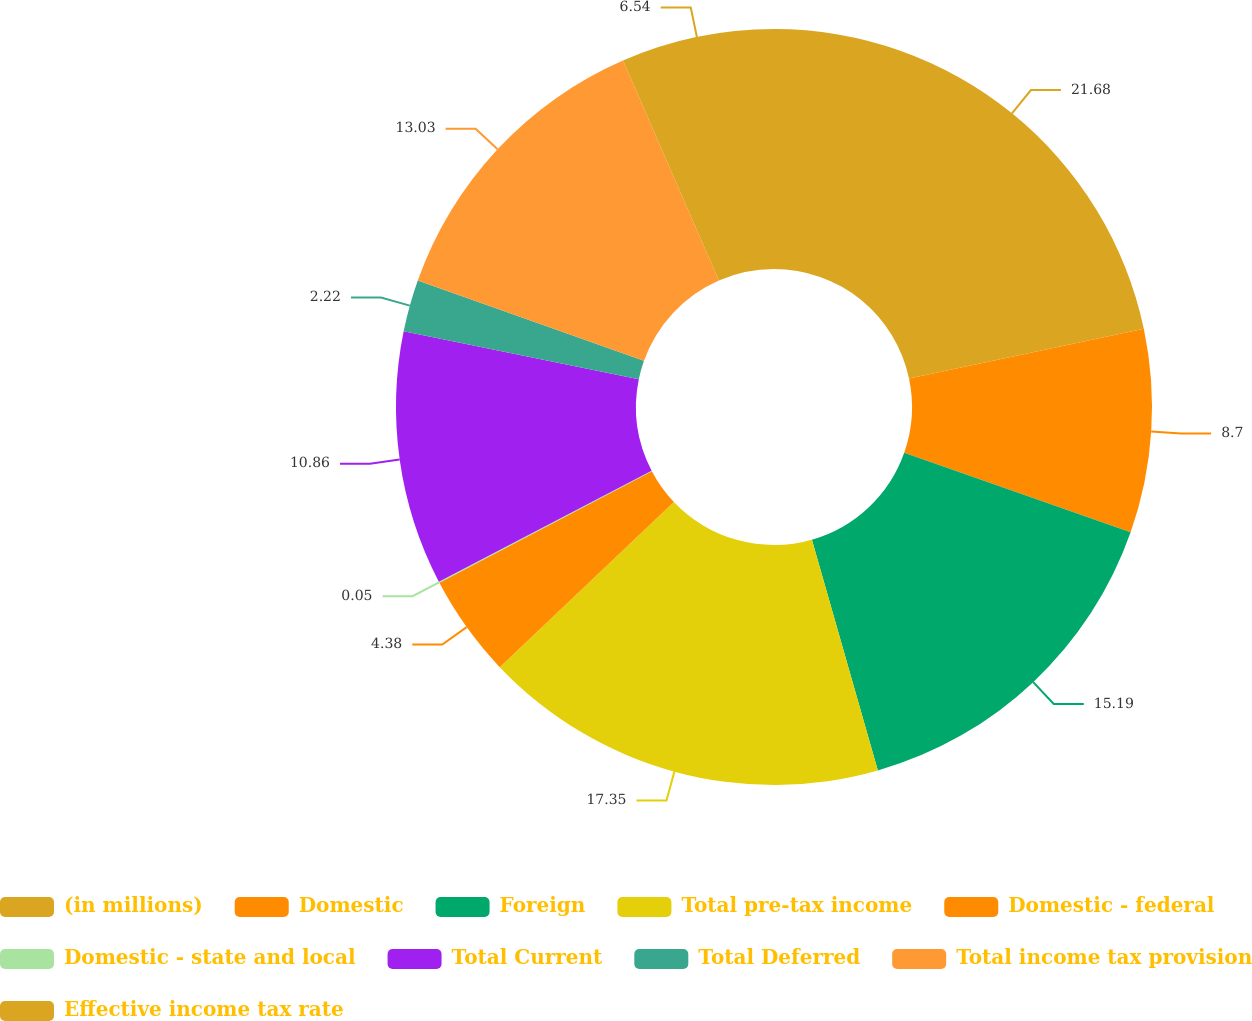Convert chart. <chart><loc_0><loc_0><loc_500><loc_500><pie_chart><fcel>(in millions)<fcel>Domestic<fcel>Foreign<fcel>Total pre-tax income<fcel>Domestic - federal<fcel>Domestic - state and local<fcel>Total Current<fcel>Total Deferred<fcel>Total income tax provision<fcel>Effective income tax rate<nl><fcel>21.68%<fcel>8.7%<fcel>15.19%<fcel>17.35%<fcel>4.38%<fcel>0.05%<fcel>10.86%<fcel>2.22%<fcel>13.03%<fcel>6.54%<nl></chart> 